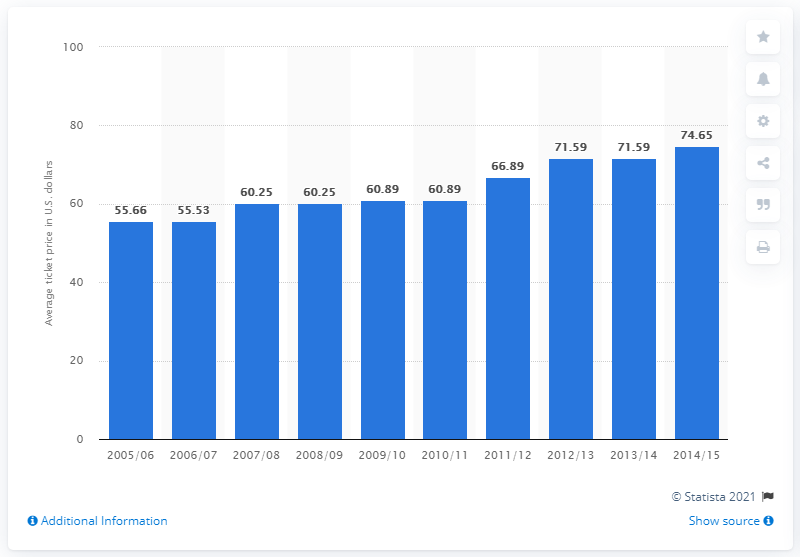Point out several critical features in this image. During the 2005/2006 season, the average ticket price was 55.66 dollars. 